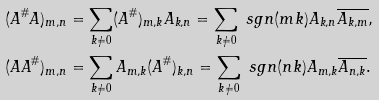<formula> <loc_0><loc_0><loc_500><loc_500>& ( A ^ { \# } A ) _ { m , n } = \sum _ { k \neq 0 } ( A ^ { \# } ) _ { m , k } A _ { k , n } = \sum _ { k \neq 0 } \ s g n ( m k ) A _ { k , n } \overline { A _ { k , m } } , \\ & ( A A ^ { \# } ) _ { m , n } = \sum _ { k \neq 0 } A _ { m , k } ( A ^ { \# } ) _ { k , n } = \sum _ { k \neq 0 } \ s g n ( n k ) A _ { m , k } \overline { A _ { n , k } } .</formula> 